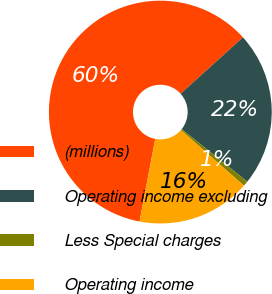Convert chart. <chart><loc_0><loc_0><loc_500><loc_500><pie_chart><fcel>(millions)<fcel>Operating income excluding<fcel>Less Special charges<fcel>Operating income<nl><fcel>60.31%<fcel>22.45%<fcel>0.75%<fcel>16.49%<nl></chart> 